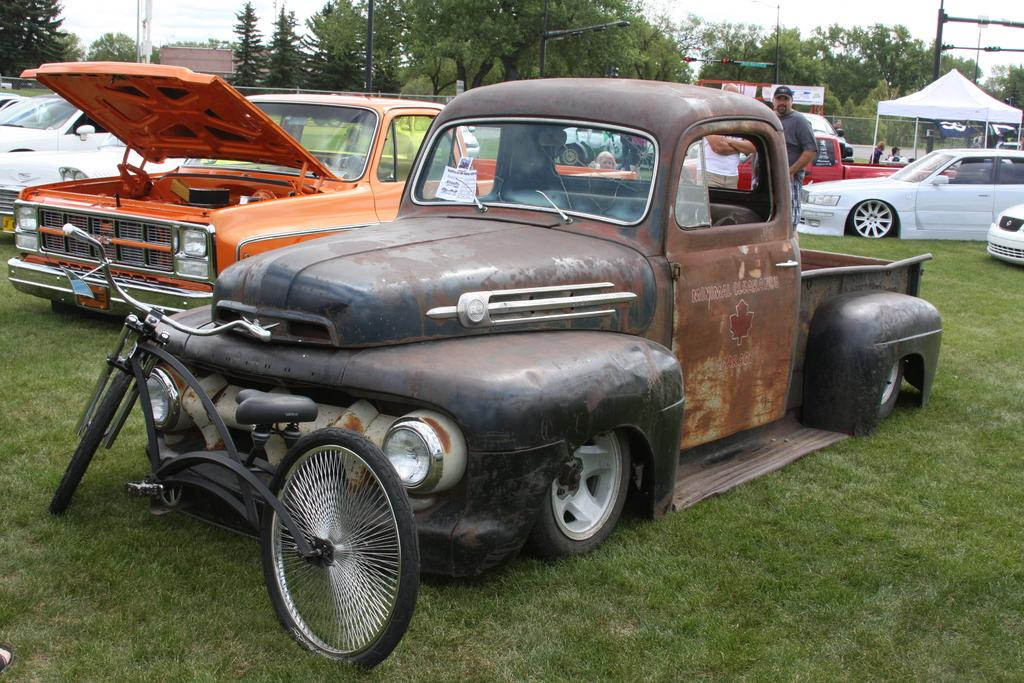What types of objects are on the ground in the image? There are vehicles on the ground in the image. What type of natural vegetation is present in the image? There are trees and grass in the image. Who or what can be seen in the image? There are people in the image. What structures are present in the image? There are poles and a fence in the image. What additional features can be seen in the image? There is a tent in the image. What can be seen in the background of the image? There is a building and the sky visible in the background of the image. Can you tell me how many shoes are visible in the image? There is no mention of shoes in the image, so it is not possible to determine how many are visible. Is there any quicksand present in the image? There is no quicksand present in the image. 